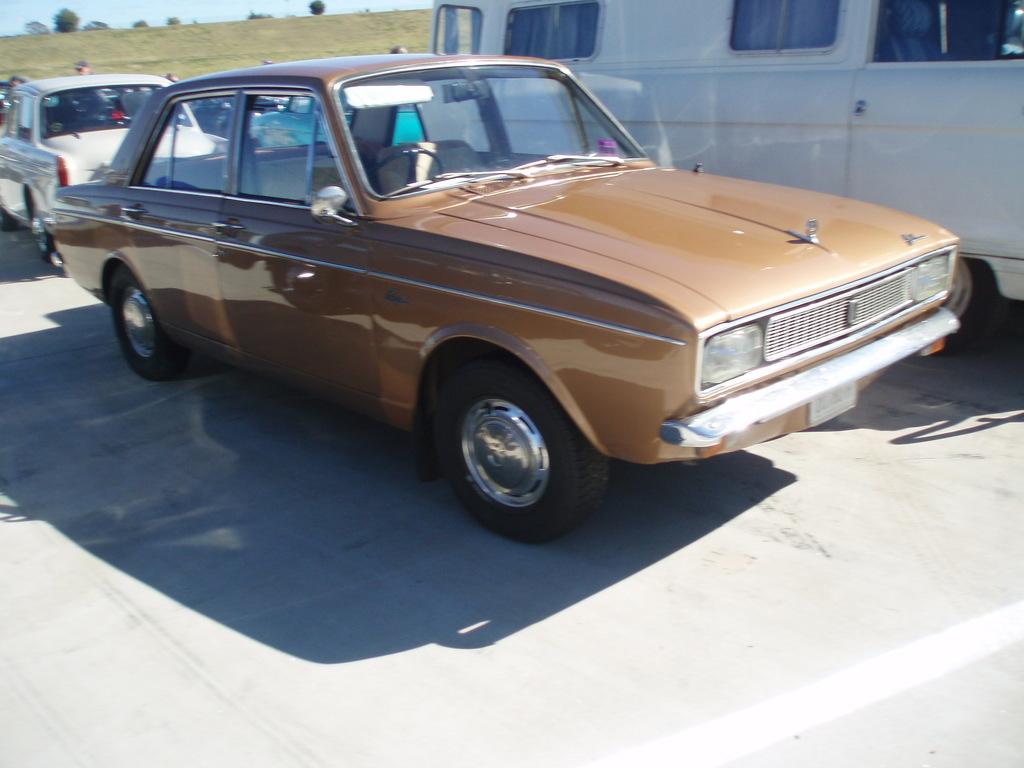What types of objects can be seen in the image? There are vehicles in the image. Can you describe the people in the image? There are people in the foreground of the image. What can be seen in the background of the image? There are trees and grass in the background of the image. What is visible at the top of the image? The sky is visible at the top of the image. What is located at the bottom of the image? There is a road at the bottom of the image. Where is the hose located in the image? There is no hose present in the image. What type of sack is being carried by the people in the image? There is no sack being carried by the people in the image. 